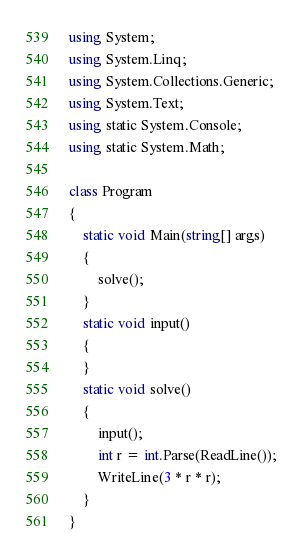Convert code to text. <code><loc_0><loc_0><loc_500><loc_500><_C#_>using System;
using System.Linq;
using System.Collections.Generic;
using System.Text;
using static System.Console;
using static System.Math;

class Program
{
    static void Main(string[] args)
    {
        solve();
    }
    static void input()
    {
    }
    static void solve()
    {
        input();
        int r = int.Parse(ReadLine());
        WriteLine(3 * r * r);
    }
}</code> 